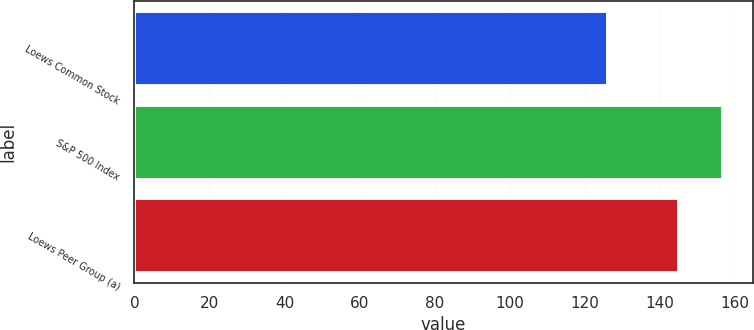Convert chart. <chart><loc_0><loc_0><loc_500><loc_500><bar_chart><fcel>Loews Common Stock<fcel>S&P 500 Index<fcel>Loews Peer Group (a)<nl><fcel>126.23<fcel>156.82<fcel>145.12<nl></chart> 